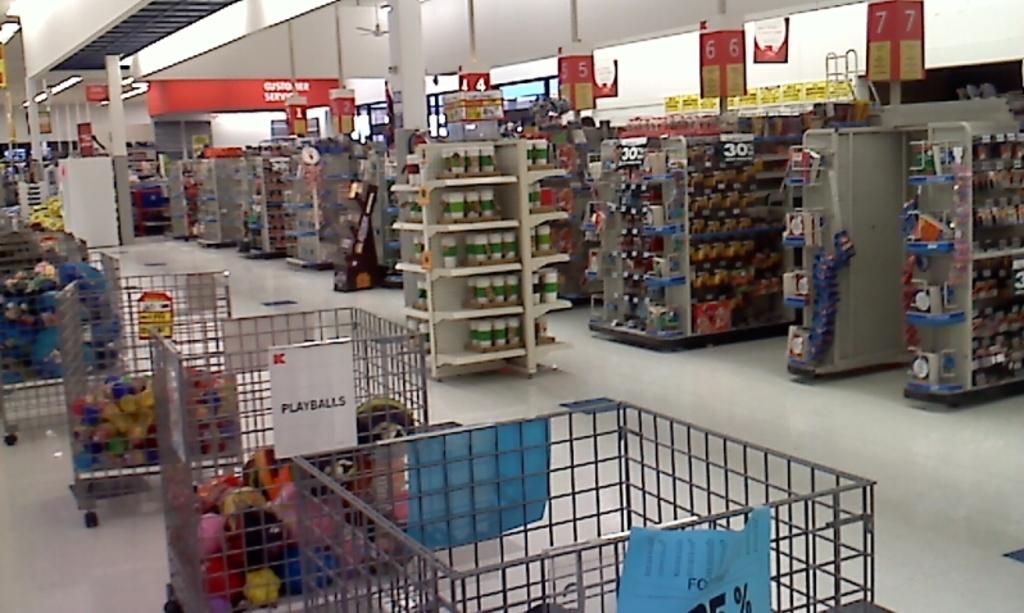<image>
Create a compact narrative representing the image presented. a Kmart store has a bin labeled Playballs 